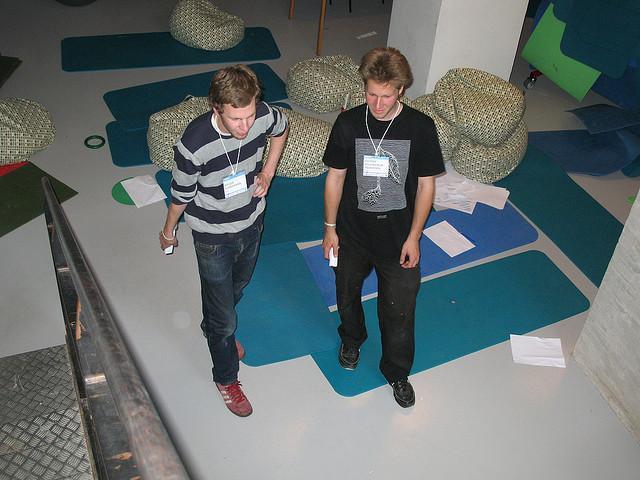How many bean bag chairs are in this photo?
Give a very brief answer. 8. How many people are there?
Give a very brief answer. 2. 